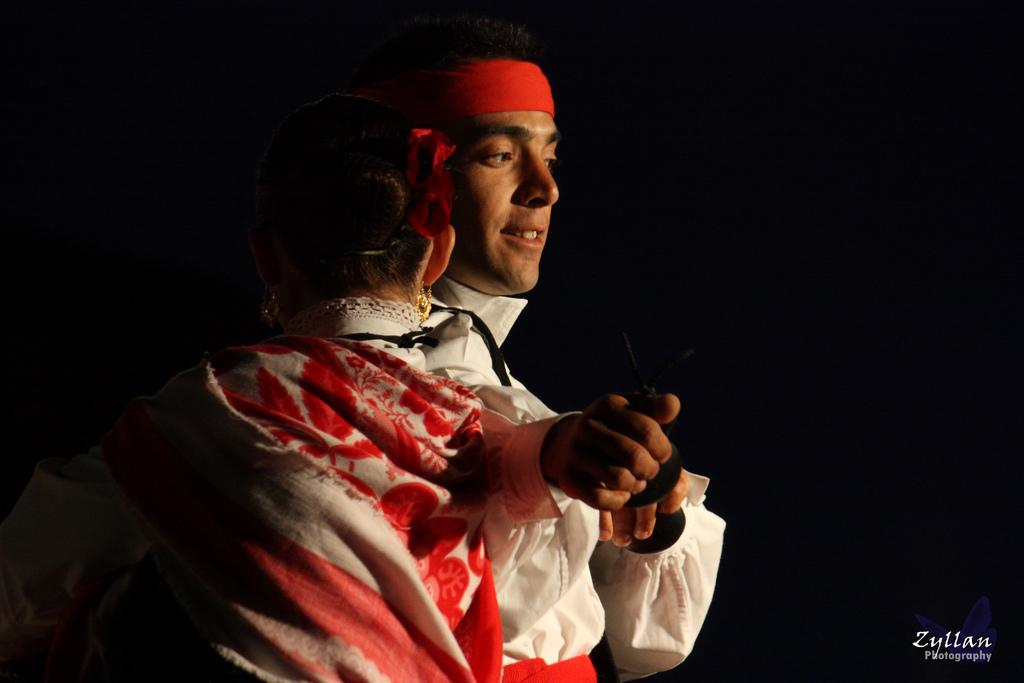How many people are in the image? There are persons in the image, but the exact number is not specified. What are the persons wearing? The persons are wearing clothes. What can be observed about the background of the image? The background of the image is dark. Where is the text located in the image? The text is in the bottom right of the image. What type of chin can be seen on the zebra in the image? There is no zebra present in the image, and therefore no chin can be observed. What is the persons having for lunch in the image? The facts do not mention any lunch or food being consumed in the image. 